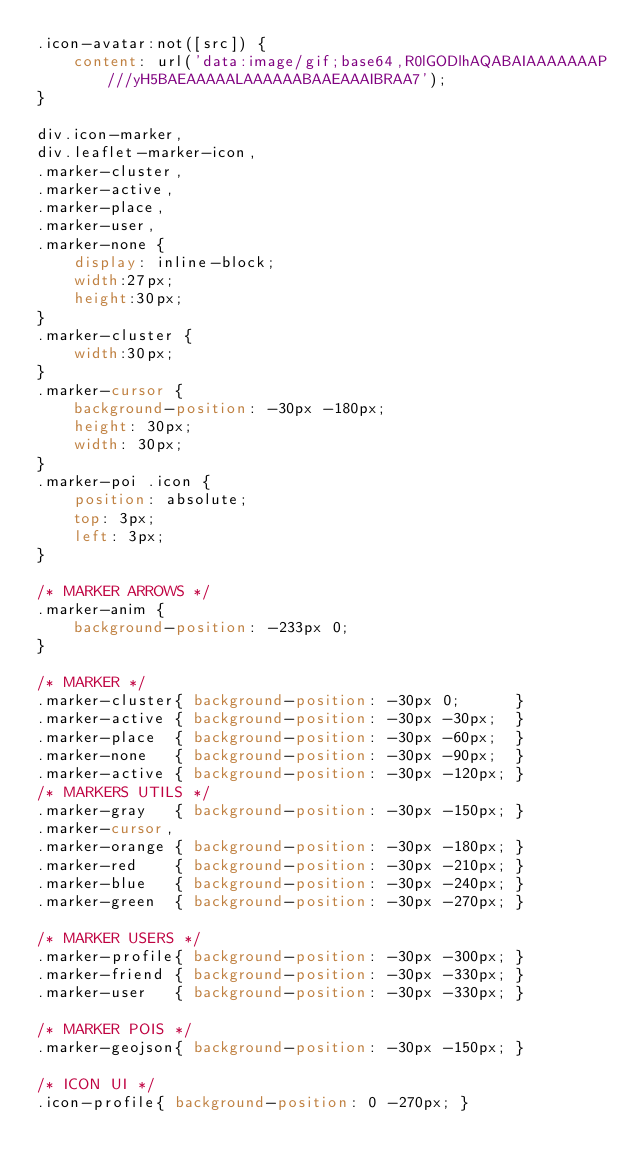<code> <loc_0><loc_0><loc_500><loc_500><_CSS_>.icon-avatar:not([src]) {
    content: url('data:image/gif;base64,R0lGODlhAQABAIAAAAAAAP///yH5BAEAAAAALAAAAAABAAEAAAIBRAA7');
}

div.icon-marker,
div.leaflet-marker-icon,
.marker-cluster,
.marker-active,
.marker-place,
.marker-user,
.marker-none {
	display: inline-block;
	width:27px;
	height:30px;
}
.marker-cluster {
	width:30px;
}
.marker-cursor {
	background-position: -30px -180px;
	height: 30px;
	width: 30px;
}
.marker-poi .icon {
	position: absolute;
	top: 3px;
	left: 3px;
}

/* MARKER ARROWS */
.marker-anim {
	background-position: -233px 0;
}

/* MARKER */
.marker-cluster{ background-position: -30px 0;      } 
.marker-active { background-position: -30px -30px;  } 
.marker-place  { background-position: -30px -60px;  } 
.marker-none   { background-position: -30px -90px;  } 
.marker-active { background-position: -30px -120px; } 
/* MARKERS UTILS */
.marker-gray   { background-position: -30px -150px; }
.marker-cursor,
.marker-orange { background-position: -30px -180px; }
.marker-red    { background-position: -30px -210px; }
.marker-blue   { background-position: -30px -240px; }
.marker-green  { background-position: -30px -270px; }

/* MARKER USERS */
.marker-profile{ background-position: -30px -300px; } 
.marker-friend { background-position: -30px -330px; } 
.marker-user   { background-position: -30px -330px; } 

/* MARKER POIS */
.marker-geojson{ background-position: -30px -150px; }

/* ICON UI */
.icon-profile{ background-position: 0 -270px; } </code> 